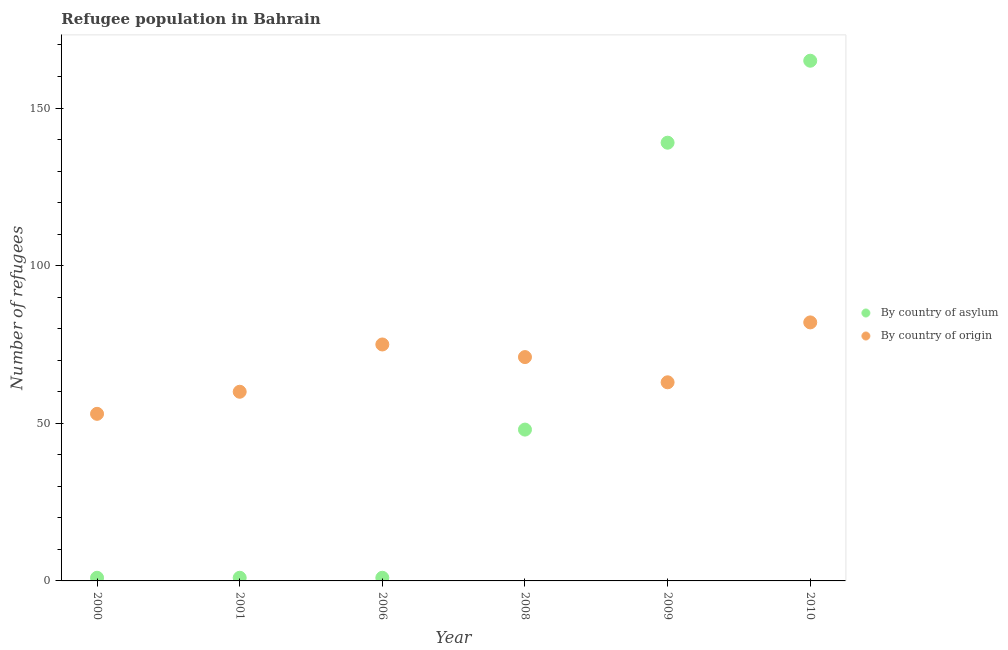What is the number of refugees by country of origin in 2000?
Provide a short and direct response. 53. Across all years, what is the maximum number of refugees by country of origin?
Keep it short and to the point. 82. Across all years, what is the minimum number of refugees by country of asylum?
Your answer should be compact. 1. In which year was the number of refugees by country of asylum maximum?
Keep it short and to the point. 2010. In which year was the number of refugees by country of asylum minimum?
Your answer should be compact. 2000. What is the total number of refugees by country of asylum in the graph?
Provide a succinct answer. 355. What is the difference between the number of refugees by country of asylum in 2000 and that in 2008?
Your answer should be compact. -47. What is the difference between the number of refugees by country of origin in 2000 and the number of refugees by country of asylum in 2008?
Ensure brevity in your answer.  5. What is the average number of refugees by country of origin per year?
Give a very brief answer. 67.33. In the year 2008, what is the difference between the number of refugees by country of asylum and number of refugees by country of origin?
Provide a succinct answer. -23. In how many years, is the number of refugees by country of origin greater than 100?
Provide a short and direct response. 0. What is the ratio of the number of refugees by country of origin in 2001 to that in 2009?
Offer a very short reply. 0.95. What is the difference between the highest and the lowest number of refugees by country of origin?
Offer a very short reply. 29. Is the sum of the number of refugees by country of origin in 2001 and 2008 greater than the maximum number of refugees by country of asylum across all years?
Make the answer very short. No. Is the number of refugees by country of asylum strictly less than the number of refugees by country of origin over the years?
Offer a terse response. No. How many dotlines are there?
Make the answer very short. 2. How many years are there in the graph?
Keep it short and to the point. 6. What is the difference between two consecutive major ticks on the Y-axis?
Offer a very short reply. 50. Are the values on the major ticks of Y-axis written in scientific E-notation?
Provide a succinct answer. No. Does the graph contain grids?
Give a very brief answer. No. How are the legend labels stacked?
Provide a short and direct response. Vertical. What is the title of the graph?
Keep it short and to the point. Refugee population in Bahrain. What is the label or title of the X-axis?
Offer a terse response. Year. What is the label or title of the Y-axis?
Give a very brief answer. Number of refugees. What is the Number of refugees of By country of asylum in 2001?
Your response must be concise. 1. What is the Number of refugees in By country of origin in 2001?
Your response must be concise. 60. What is the Number of refugees of By country of asylum in 2008?
Provide a short and direct response. 48. What is the Number of refugees in By country of origin in 2008?
Make the answer very short. 71. What is the Number of refugees in By country of asylum in 2009?
Provide a short and direct response. 139. What is the Number of refugees of By country of origin in 2009?
Your response must be concise. 63. What is the Number of refugees in By country of asylum in 2010?
Your answer should be compact. 165. What is the Number of refugees of By country of origin in 2010?
Your response must be concise. 82. Across all years, what is the maximum Number of refugees in By country of asylum?
Your answer should be very brief. 165. Across all years, what is the maximum Number of refugees in By country of origin?
Your response must be concise. 82. Across all years, what is the minimum Number of refugees of By country of asylum?
Keep it short and to the point. 1. What is the total Number of refugees in By country of asylum in the graph?
Make the answer very short. 355. What is the total Number of refugees in By country of origin in the graph?
Your response must be concise. 404. What is the difference between the Number of refugees in By country of origin in 2000 and that in 2001?
Ensure brevity in your answer.  -7. What is the difference between the Number of refugees of By country of asylum in 2000 and that in 2006?
Ensure brevity in your answer.  0. What is the difference between the Number of refugees in By country of asylum in 2000 and that in 2008?
Ensure brevity in your answer.  -47. What is the difference between the Number of refugees of By country of origin in 2000 and that in 2008?
Your response must be concise. -18. What is the difference between the Number of refugees of By country of asylum in 2000 and that in 2009?
Provide a succinct answer. -138. What is the difference between the Number of refugees in By country of origin in 2000 and that in 2009?
Offer a terse response. -10. What is the difference between the Number of refugees of By country of asylum in 2000 and that in 2010?
Your answer should be compact. -164. What is the difference between the Number of refugees in By country of origin in 2000 and that in 2010?
Offer a very short reply. -29. What is the difference between the Number of refugees in By country of asylum in 2001 and that in 2006?
Keep it short and to the point. 0. What is the difference between the Number of refugees in By country of origin in 2001 and that in 2006?
Provide a succinct answer. -15. What is the difference between the Number of refugees in By country of asylum in 2001 and that in 2008?
Offer a very short reply. -47. What is the difference between the Number of refugees of By country of origin in 2001 and that in 2008?
Ensure brevity in your answer.  -11. What is the difference between the Number of refugees of By country of asylum in 2001 and that in 2009?
Your answer should be very brief. -138. What is the difference between the Number of refugees in By country of asylum in 2001 and that in 2010?
Your answer should be very brief. -164. What is the difference between the Number of refugees in By country of asylum in 2006 and that in 2008?
Give a very brief answer. -47. What is the difference between the Number of refugees in By country of origin in 2006 and that in 2008?
Keep it short and to the point. 4. What is the difference between the Number of refugees in By country of asylum in 2006 and that in 2009?
Keep it short and to the point. -138. What is the difference between the Number of refugees in By country of origin in 2006 and that in 2009?
Keep it short and to the point. 12. What is the difference between the Number of refugees of By country of asylum in 2006 and that in 2010?
Offer a terse response. -164. What is the difference between the Number of refugees of By country of asylum in 2008 and that in 2009?
Your answer should be very brief. -91. What is the difference between the Number of refugees in By country of asylum in 2008 and that in 2010?
Offer a very short reply. -117. What is the difference between the Number of refugees of By country of origin in 2008 and that in 2010?
Keep it short and to the point. -11. What is the difference between the Number of refugees in By country of asylum in 2009 and that in 2010?
Offer a terse response. -26. What is the difference between the Number of refugees of By country of origin in 2009 and that in 2010?
Your response must be concise. -19. What is the difference between the Number of refugees in By country of asylum in 2000 and the Number of refugees in By country of origin in 2001?
Offer a terse response. -59. What is the difference between the Number of refugees in By country of asylum in 2000 and the Number of refugees in By country of origin in 2006?
Offer a very short reply. -74. What is the difference between the Number of refugees in By country of asylum in 2000 and the Number of refugees in By country of origin in 2008?
Your answer should be compact. -70. What is the difference between the Number of refugees in By country of asylum in 2000 and the Number of refugees in By country of origin in 2009?
Your answer should be very brief. -62. What is the difference between the Number of refugees in By country of asylum in 2000 and the Number of refugees in By country of origin in 2010?
Your answer should be compact. -81. What is the difference between the Number of refugees of By country of asylum in 2001 and the Number of refugees of By country of origin in 2006?
Provide a short and direct response. -74. What is the difference between the Number of refugees of By country of asylum in 2001 and the Number of refugees of By country of origin in 2008?
Offer a terse response. -70. What is the difference between the Number of refugees of By country of asylum in 2001 and the Number of refugees of By country of origin in 2009?
Ensure brevity in your answer.  -62. What is the difference between the Number of refugees of By country of asylum in 2001 and the Number of refugees of By country of origin in 2010?
Provide a short and direct response. -81. What is the difference between the Number of refugees in By country of asylum in 2006 and the Number of refugees in By country of origin in 2008?
Provide a succinct answer. -70. What is the difference between the Number of refugees of By country of asylum in 2006 and the Number of refugees of By country of origin in 2009?
Give a very brief answer. -62. What is the difference between the Number of refugees in By country of asylum in 2006 and the Number of refugees in By country of origin in 2010?
Ensure brevity in your answer.  -81. What is the difference between the Number of refugees of By country of asylum in 2008 and the Number of refugees of By country of origin in 2009?
Provide a short and direct response. -15. What is the difference between the Number of refugees of By country of asylum in 2008 and the Number of refugees of By country of origin in 2010?
Make the answer very short. -34. What is the difference between the Number of refugees in By country of asylum in 2009 and the Number of refugees in By country of origin in 2010?
Offer a very short reply. 57. What is the average Number of refugees in By country of asylum per year?
Your answer should be very brief. 59.17. What is the average Number of refugees of By country of origin per year?
Your answer should be very brief. 67.33. In the year 2000, what is the difference between the Number of refugees of By country of asylum and Number of refugees of By country of origin?
Offer a terse response. -52. In the year 2001, what is the difference between the Number of refugees in By country of asylum and Number of refugees in By country of origin?
Offer a terse response. -59. In the year 2006, what is the difference between the Number of refugees in By country of asylum and Number of refugees in By country of origin?
Offer a terse response. -74. In the year 2009, what is the difference between the Number of refugees of By country of asylum and Number of refugees of By country of origin?
Provide a short and direct response. 76. What is the ratio of the Number of refugees in By country of asylum in 2000 to that in 2001?
Offer a terse response. 1. What is the ratio of the Number of refugees of By country of origin in 2000 to that in 2001?
Keep it short and to the point. 0.88. What is the ratio of the Number of refugees in By country of origin in 2000 to that in 2006?
Provide a succinct answer. 0.71. What is the ratio of the Number of refugees of By country of asylum in 2000 to that in 2008?
Offer a very short reply. 0.02. What is the ratio of the Number of refugees in By country of origin in 2000 to that in 2008?
Your answer should be compact. 0.75. What is the ratio of the Number of refugees in By country of asylum in 2000 to that in 2009?
Offer a very short reply. 0.01. What is the ratio of the Number of refugees in By country of origin in 2000 to that in 2009?
Your response must be concise. 0.84. What is the ratio of the Number of refugees of By country of asylum in 2000 to that in 2010?
Your answer should be compact. 0.01. What is the ratio of the Number of refugees in By country of origin in 2000 to that in 2010?
Offer a very short reply. 0.65. What is the ratio of the Number of refugees of By country of asylum in 2001 to that in 2006?
Provide a short and direct response. 1. What is the ratio of the Number of refugees in By country of origin in 2001 to that in 2006?
Offer a very short reply. 0.8. What is the ratio of the Number of refugees in By country of asylum in 2001 to that in 2008?
Ensure brevity in your answer.  0.02. What is the ratio of the Number of refugees in By country of origin in 2001 to that in 2008?
Your response must be concise. 0.85. What is the ratio of the Number of refugees in By country of asylum in 2001 to that in 2009?
Ensure brevity in your answer.  0.01. What is the ratio of the Number of refugees of By country of origin in 2001 to that in 2009?
Your answer should be compact. 0.95. What is the ratio of the Number of refugees in By country of asylum in 2001 to that in 2010?
Offer a terse response. 0.01. What is the ratio of the Number of refugees in By country of origin in 2001 to that in 2010?
Make the answer very short. 0.73. What is the ratio of the Number of refugees of By country of asylum in 2006 to that in 2008?
Make the answer very short. 0.02. What is the ratio of the Number of refugees of By country of origin in 2006 to that in 2008?
Your response must be concise. 1.06. What is the ratio of the Number of refugees in By country of asylum in 2006 to that in 2009?
Give a very brief answer. 0.01. What is the ratio of the Number of refugees in By country of origin in 2006 to that in 2009?
Ensure brevity in your answer.  1.19. What is the ratio of the Number of refugees of By country of asylum in 2006 to that in 2010?
Make the answer very short. 0.01. What is the ratio of the Number of refugees in By country of origin in 2006 to that in 2010?
Offer a very short reply. 0.91. What is the ratio of the Number of refugees of By country of asylum in 2008 to that in 2009?
Offer a very short reply. 0.35. What is the ratio of the Number of refugees in By country of origin in 2008 to that in 2009?
Provide a short and direct response. 1.13. What is the ratio of the Number of refugees of By country of asylum in 2008 to that in 2010?
Your response must be concise. 0.29. What is the ratio of the Number of refugees of By country of origin in 2008 to that in 2010?
Make the answer very short. 0.87. What is the ratio of the Number of refugees in By country of asylum in 2009 to that in 2010?
Your answer should be very brief. 0.84. What is the ratio of the Number of refugees in By country of origin in 2009 to that in 2010?
Your response must be concise. 0.77. What is the difference between the highest and the second highest Number of refugees of By country of origin?
Give a very brief answer. 7. What is the difference between the highest and the lowest Number of refugees in By country of asylum?
Give a very brief answer. 164. 